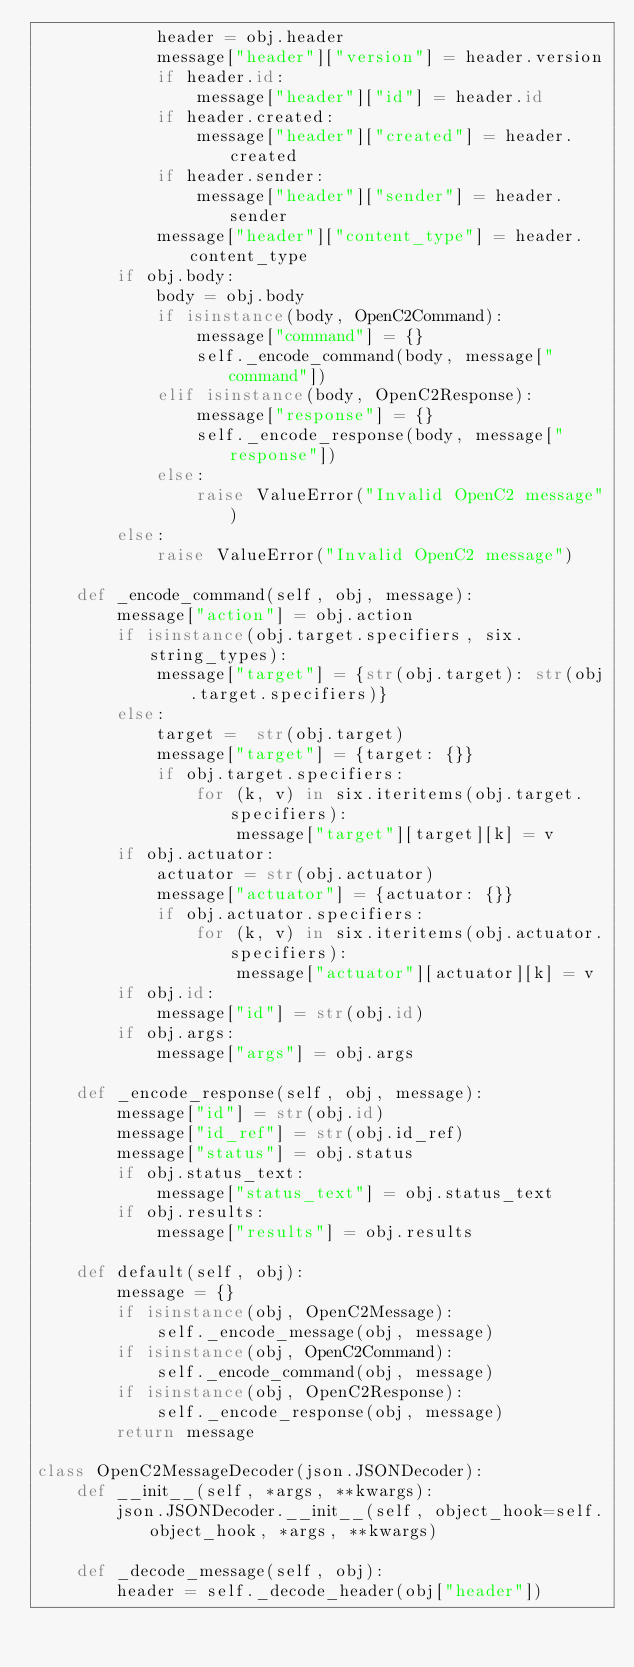Convert code to text. <code><loc_0><loc_0><loc_500><loc_500><_Python_>            header = obj.header
            message["header"]["version"] = header.version
            if header.id:
                message["header"]["id"] = header.id
            if header.created:
                message["header"]["created"] = header.created
            if header.sender:
                message["header"]["sender"] = header.sender
            message["header"]["content_type"] = header.content_type
        if obj.body:
            body = obj.body
            if isinstance(body, OpenC2Command):
                message["command"] = {}
                self._encode_command(body, message["command"])
            elif isinstance(body, OpenC2Response):
                message["response"] = {}
                self._encode_response(body, message["response"])
            else:
                raise ValueError("Invalid OpenC2 message")
        else:
            raise ValueError("Invalid OpenC2 message")

    def _encode_command(self, obj, message):
        message["action"] = obj.action
        if isinstance(obj.target.specifiers, six.string_types):
            message["target"] = {str(obj.target): str(obj.target.specifiers)}
        else:
            target =  str(obj.target)
            message["target"] = {target: {}}
            if obj.target.specifiers:
                for (k, v) in six.iteritems(obj.target.specifiers):
                    message["target"][target][k] = v
        if obj.actuator:
            actuator = str(obj.actuator)
            message["actuator"] = {actuator: {}}
            if obj.actuator.specifiers:
                for (k, v) in six.iteritems(obj.actuator.specifiers):
                    message["actuator"][actuator][k] = v
        if obj.id:
            message["id"] = str(obj.id)
        if obj.args:
            message["args"] = obj.args

    def _encode_response(self, obj, message):
        message["id"] = str(obj.id)
        message["id_ref"] = str(obj.id_ref)
        message["status"] = obj.status
        if obj.status_text:
            message["status_text"] = obj.status_text
        if obj.results:
            message["results"] = obj.results

    def default(self, obj):
        message = {}
        if isinstance(obj, OpenC2Message):
            self._encode_message(obj, message)
        if isinstance(obj, OpenC2Command):
            self._encode_command(obj, message)
        if isinstance(obj, OpenC2Response):
            self._encode_response(obj, message)
        return message

class OpenC2MessageDecoder(json.JSONDecoder):
    def __init__(self, *args, **kwargs):
        json.JSONDecoder.__init__(self, object_hook=self.object_hook, *args, **kwargs)

    def _decode_message(self, obj):
        header = self._decode_header(obj["header"])</code> 